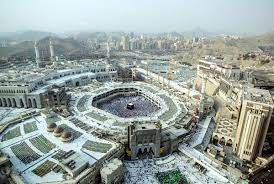Can you tell me more about the architectural styles visible in the Great Mosque of Mecca? Certainly! The Great Mosque of Mecca, known as Masjid al-Haram, showcases a blend of architectural styles that have evolved over centuries. The mosque's current design includes Ottoman, Mamluk, and modern elements. The minarets, with their slender, pointed structures, are characteristic of Ottoman design, while the large domes draw from Byzantine architectural influences. The surrounding structures have a more contemporary look, reflecting recent expansions and the need to accommodate millions of pilgrims annually. The architectural diversity symbolizes the mosque's historical and spiritual significance through time. 